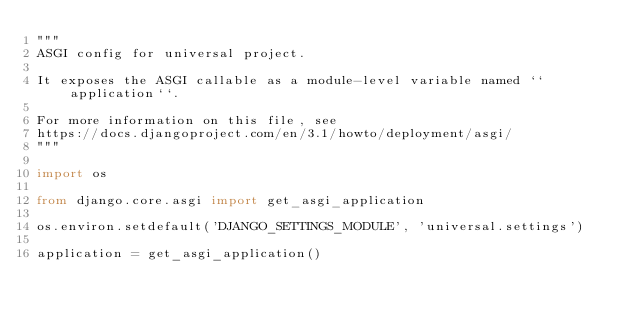<code> <loc_0><loc_0><loc_500><loc_500><_Python_>"""
ASGI config for universal project.

It exposes the ASGI callable as a module-level variable named ``application``.

For more information on this file, see
https://docs.djangoproject.com/en/3.1/howto/deployment/asgi/
"""

import os

from django.core.asgi import get_asgi_application

os.environ.setdefault('DJANGO_SETTINGS_MODULE', 'universal.settings')

application = get_asgi_application()
</code> 